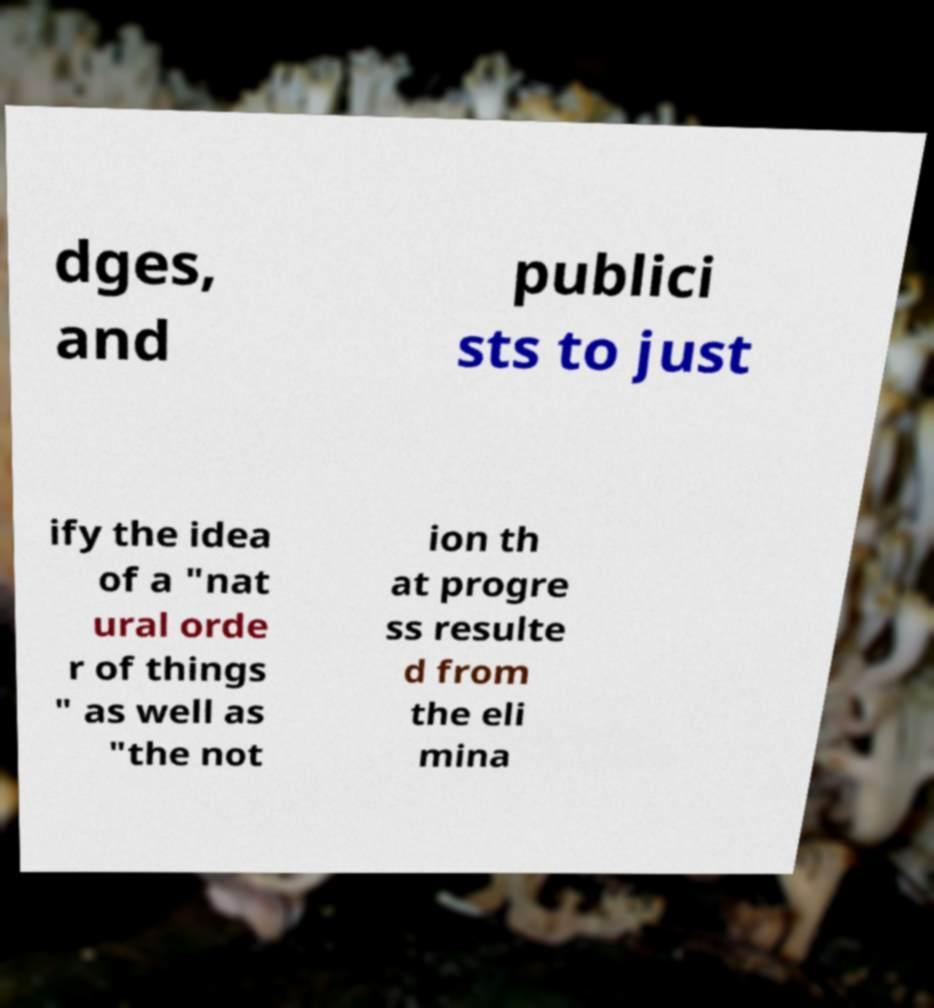Could you assist in decoding the text presented in this image and type it out clearly? dges, and publici sts to just ify the idea of a "nat ural orde r of things " as well as "the not ion th at progre ss resulte d from the eli mina 